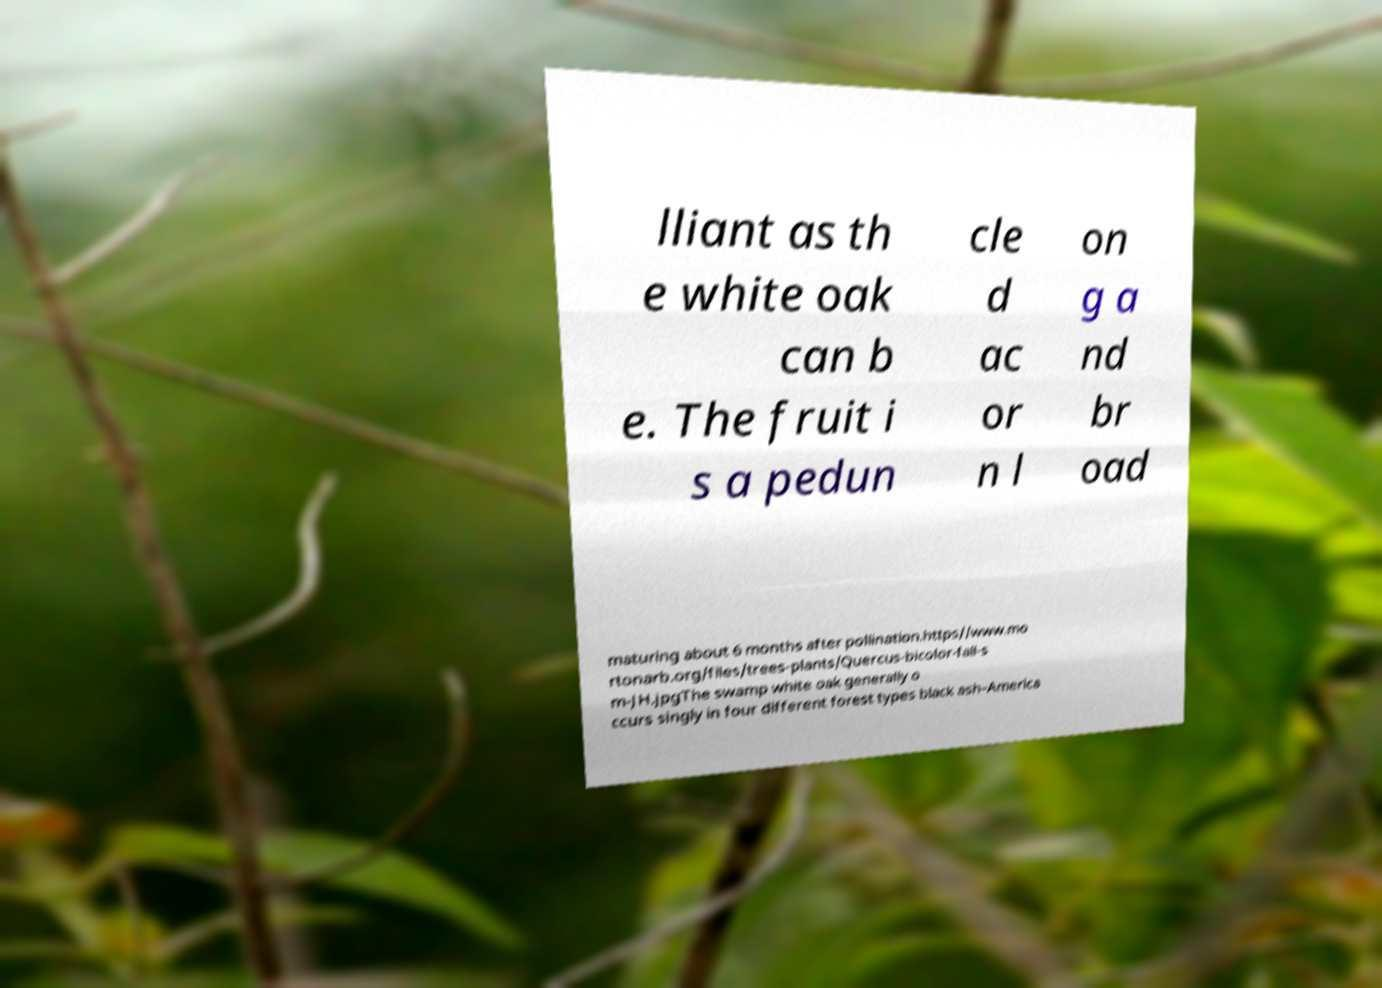Please identify and transcribe the text found in this image. lliant as th e white oak can b e. The fruit i s a pedun cle d ac or n l on g a nd br oad maturing about 6 months after pollination.https//www.mo rtonarb.org/files/trees-plants/Quercus-bicolor-fall-s m-JH.jpgThe swamp white oak generally o ccurs singly in four different forest types black ash–America 